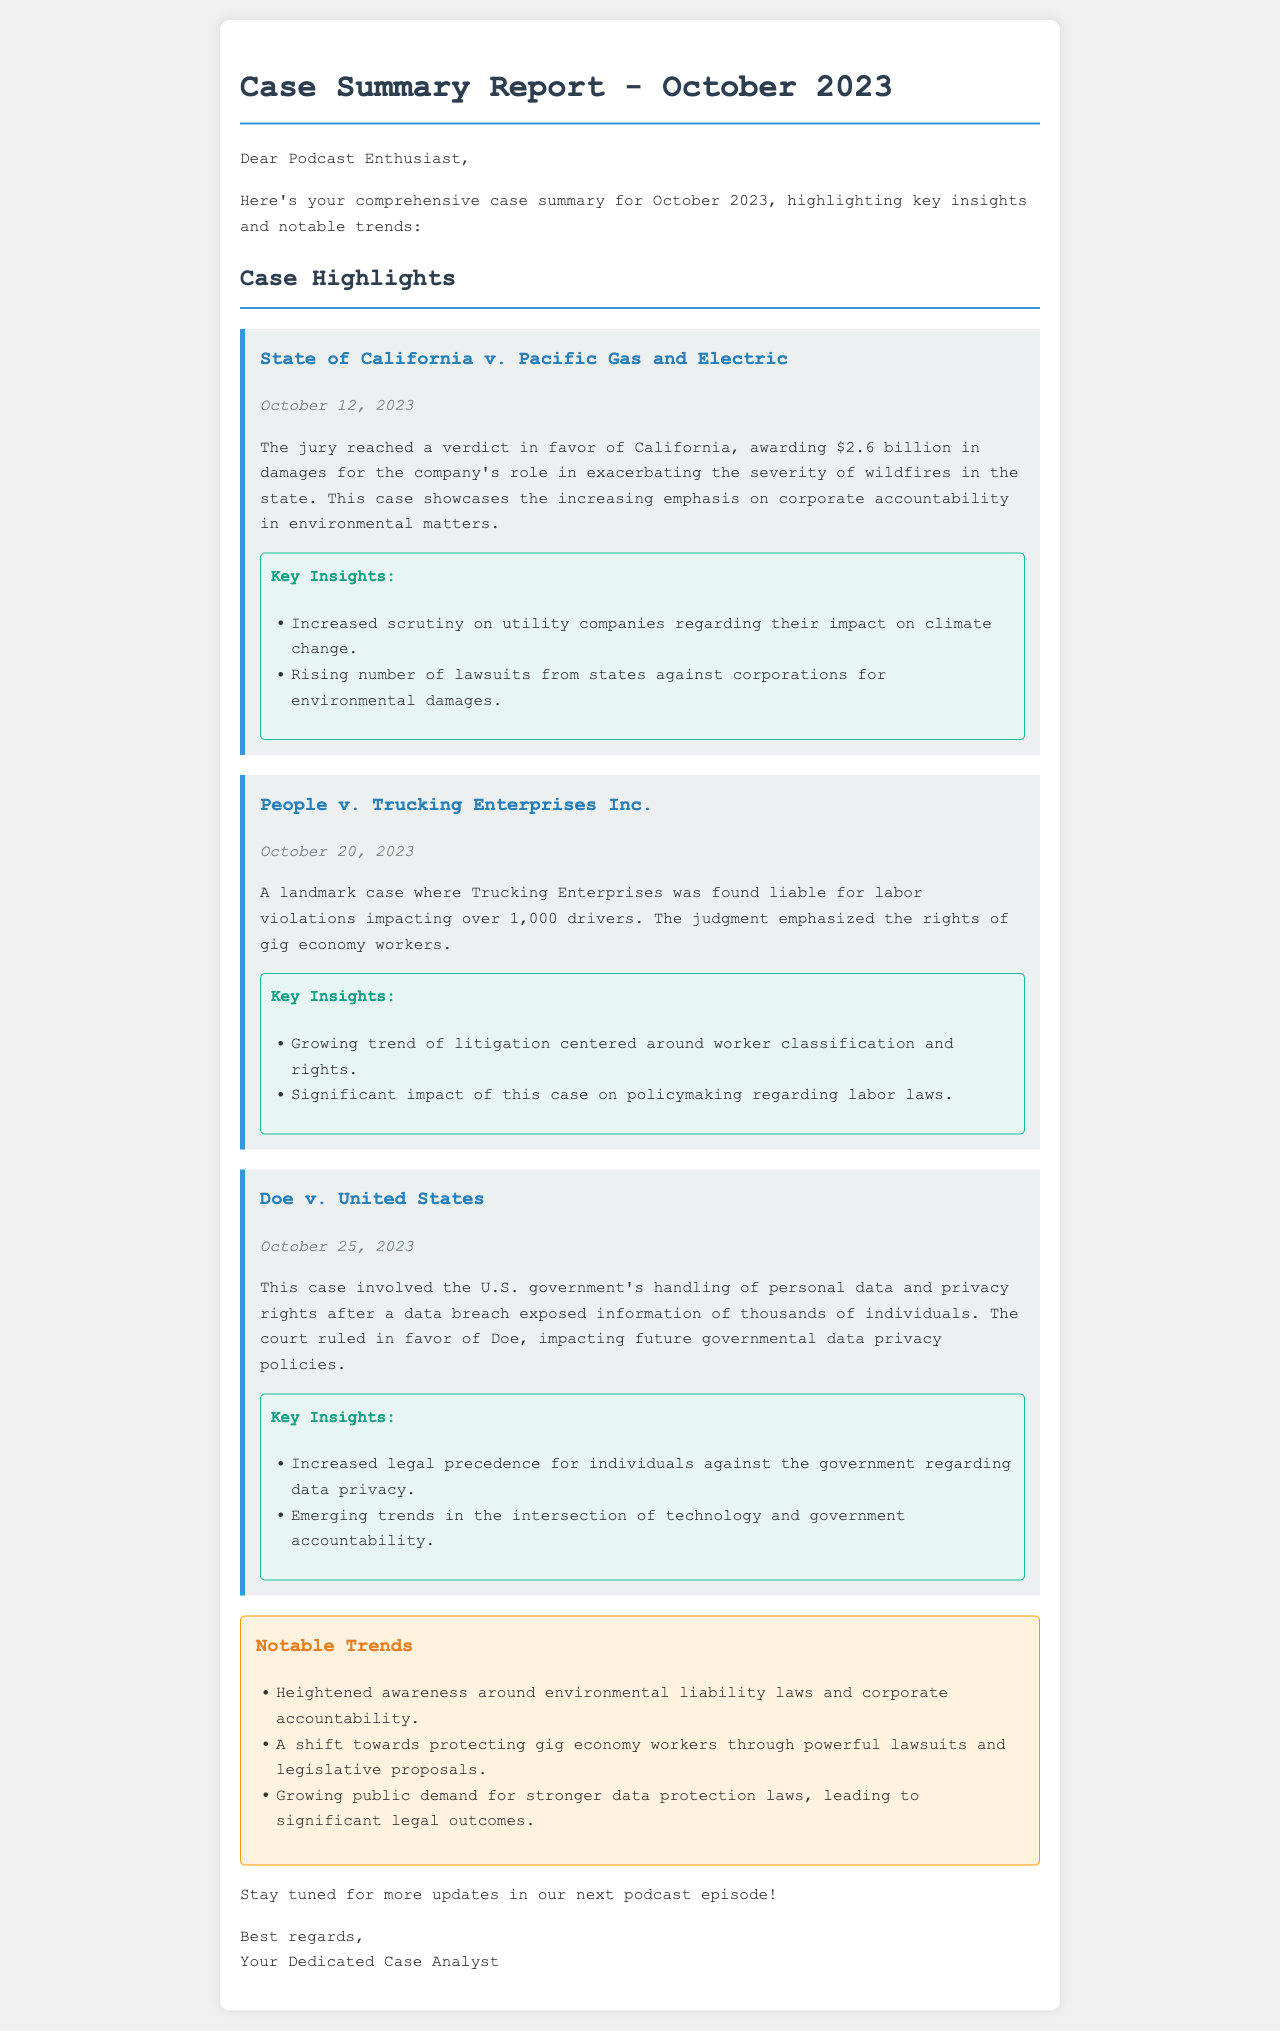What was the verdict amount in the California case? The document states that the jury awarded $2.6 billion in damages in the California case.
Answer: $2.6 billion When did the People v. Trucking Enterprises Inc. case occur? The date mentioned in the document for the People v. Trucking Enterprises Inc. case is October 20, 2023.
Answer: October 20, 2023 Which case involved the handling of personal data and privacy rights? The document specifies that Doe v. United States involved the handling of personal data and privacy rights.
Answer: Doe v. United States What trend is emerging regarding gig economy workers? The document notes a growing trend around the protection of gig economy workers through litigation.
Answer: Protection of gig economy workers Which case emphasized corporate accountability in environmental matters? The State of California v. Pacific Gas and Electric case emphasized corporate accountability in environmental matters.
Answer: State of California v. Pacific Gas and Electric What is one of the notable trends mentioned in the report? The document highlights heightened awareness around environmental liability laws as one of the notable trends.
Answer: Heightened awareness around environmental liability laws What date was the California case verdict reached? The document states that the verdict in the California case was reached on October 12, 2023.
Answer: October 12, 2023 What is the significance of the ruling in Doe v. United States? The ruling in Doe v. United States impacts future governmental data privacy policies.
Answer: Future governmental data privacy policies 